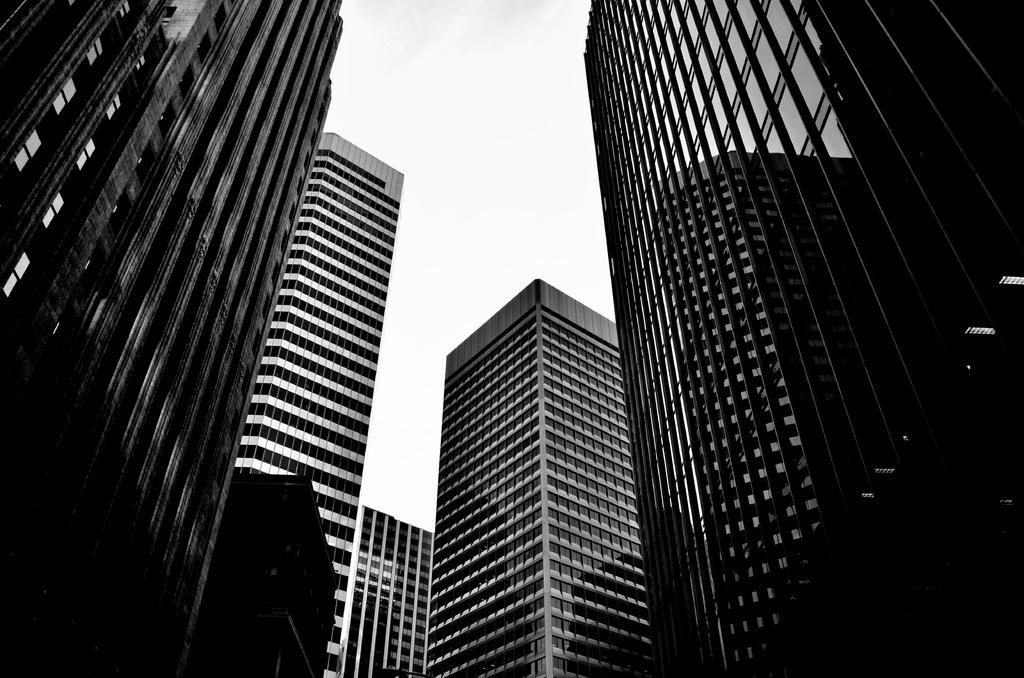What type of structures can be seen in the image? There are buildings in the image. What part of the natural environment is visible in the image? The sky is visible in the image. What type of fruit is being used to fix the buildings in the image? There is no fruit, such as a cherry, present in the image, and therefore it cannot be used to fix the buildings. 